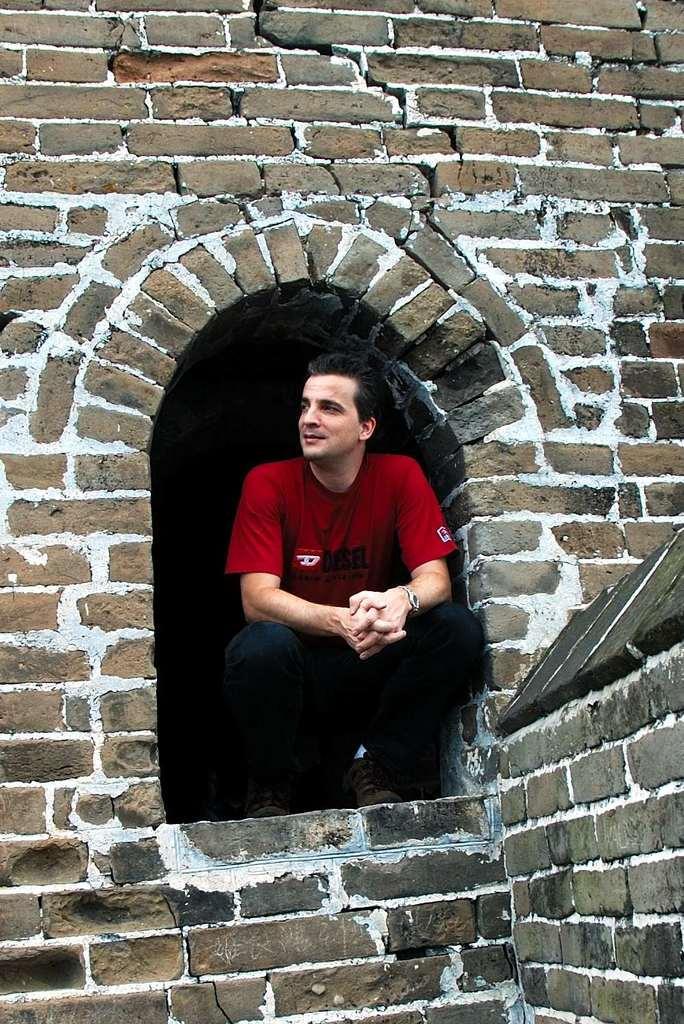Could you give a brief overview of what you see in this image? In this image we can see a man wearing red t shirt and he is present in the middle of the brick wall. 